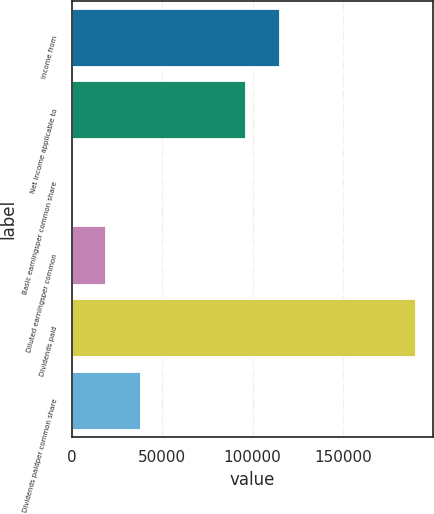Convert chart. <chart><loc_0><loc_0><loc_500><loc_500><bar_chart><fcel>Income from<fcel>Net income applicable to<fcel>Basic earningsper common share<fcel>Diluted earningsper common<fcel>Dividends paid<fcel>Dividends paidper common share<nl><fcel>115278<fcel>96266<fcel>0.71<fcel>19012.9<fcel>190123<fcel>38025.2<nl></chart> 